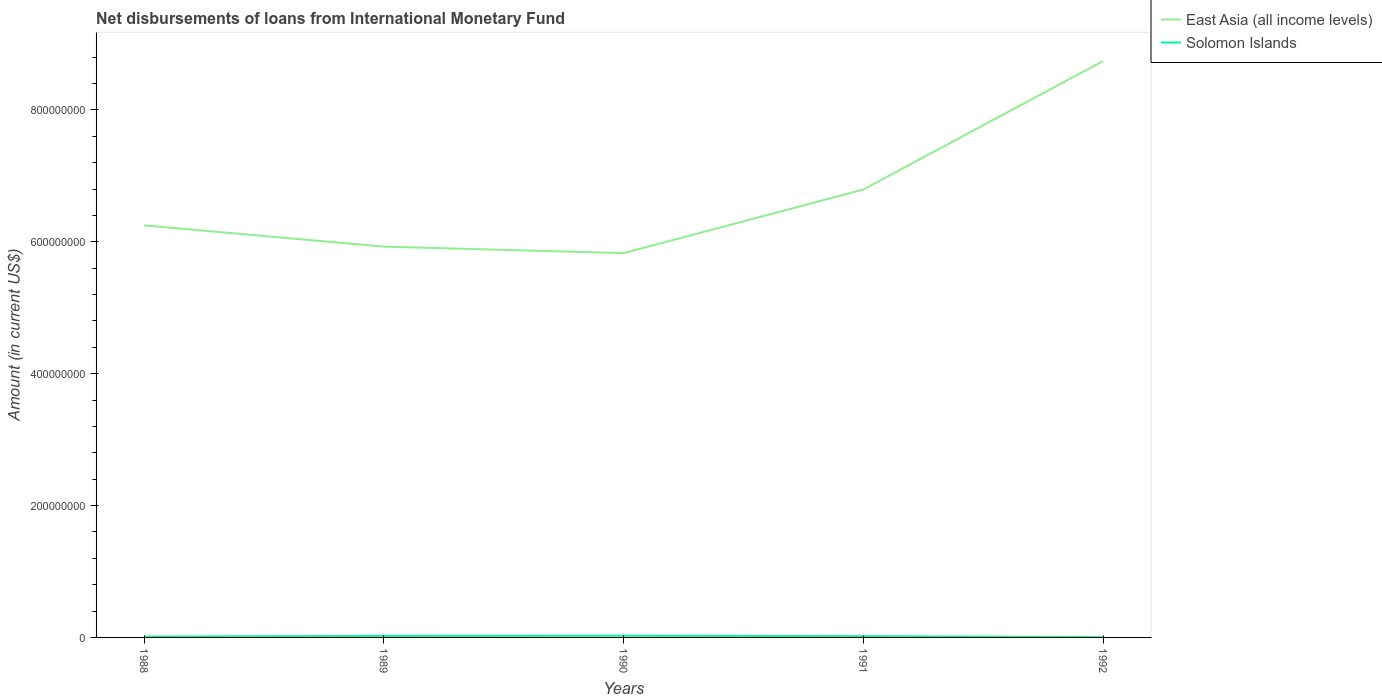Across all years, what is the maximum amount of loans disbursed in Solomon Islands?
Provide a succinct answer. 4.98e+05. In which year was the amount of loans disbursed in East Asia (all income levels) maximum?
Offer a terse response. 1990. What is the total amount of loans disbursed in Solomon Islands in the graph?
Offer a very short reply. 8.05e+05. What is the difference between the highest and the second highest amount of loans disbursed in Solomon Islands?
Ensure brevity in your answer.  2.05e+06. Is the amount of loans disbursed in East Asia (all income levels) strictly greater than the amount of loans disbursed in Solomon Islands over the years?
Provide a short and direct response. No. How many lines are there?
Keep it short and to the point. 2. How many years are there in the graph?
Your response must be concise. 5. How are the legend labels stacked?
Your response must be concise. Vertical. What is the title of the graph?
Ensure brevity in your answer.  Net disbursements of loans from International Monetary Fund. What is the label or title of the X-axis?
Give a very brief answer. Years. What is the label or title of the Y-axis?
Provide a short and direct response. Amount (in current US$). What is the Amount (in current US$) of East Asia (all income levels) in 1988?
Offer a very short reply. 6.25e+08. What is the Amount (in current US$) in Solomon Islands in 1988?
Make the answer very short. 1.30e+06. What is the Amount (in current US$) of East Asia (all income levels) in 1989?
Keep it short and to the point. 5.93e+08. What is the Amount (in current US$) in Solomon Islands in 1989?
Ensure brevity in your answer.  2.28e+06. What is the Amount (in current US$) in East Asia (all income levels) in 1990?
Give a very brief answer. 5.83e+08. What is the Amount (in current US$) in Solomon Islands in 1990?
Your answer should be compact. 2.54e+06. What is the Amount (in current US$) of East Asia (all income levels) in 1991?
Offer a terse response. 6.79e+08. What is the Amount (in current US$) in Solomon Islands in 1991?
Keep it short and to the point. 1.92e+06. What is the Amount (in current US$) in East Asia (all income levels) in 1992?
Provide a short and direct response. 8.74e+08. What is the Amount (in current US$) in Solomon Islands in 1992?
Provide a succinct answer. 4.98e+05. Across all years, what is the maximum Amount (in current US$) in East Asia (all income levels)?
Your answer should be very brief. 8.74e+08. Across all years, what is the maximum Amount (in current US$) in Solomon Islands?
Your answer should be compact. 2.54e+06. Across all years, what is the minimum Amount (in current US$) in East Asia (all income levels)?
Ensure brevity in your answer.  5.83e+08. Across all years, what is the minimum Amount (in current US$) of Solomon Islands?
Your answer should be compact. 4.98e+05. What is the total Amount (in current US$) in East Asia (all income levels) in the graph?
Keep it short and to the point. 3.35e+09. What is the total Amount (in current US$) in Solomon Islands in the graph?
Make the answer very short. 8.55e+06. What is the difference between the Amount (in current US$) in East Asia (all income levels) in 1988 and that in 1989?
Your response must be concise. 3.22e+07. What is the difference between the Amount (in current US$) in Solomon Islands in 1988 and that in 1989?
Ensure brevity in your answer.  -9.78e+05. What is the difference between the Amount (in current US$) of East Asia (all income levels) in 1988 and that in 1990?
Provide a short and direct response. 4.21e+07. What is the difference between the Amount (in current US$) in Solomon Islands in 1988 and that in 1990?
Your answer should be compact. -1.24e+06. What is the difference between the Amount (in current US$) in East Asia (all income levels) in 1988 and that in 1991?
Offer a very short reply. -5.43e+07. What is the difference between the Amount (in current US$) in Solomon Islands in 1988 and that in 1991?
Your response must be concise. -6.17e+05. What is the difference between the Amount (in current US$) in East Asia (all income levels) in 1988 and that in 1992?
Ensure brevity in your answer.  -2.49e+08. What is the difference between the Amount (in current US$) in Solomon Islands in 1988 and that in 1992?
Keep it short and to the point. 8.05e+05. What is the difference between the Amount (in current US$) of East Asia (all income levels) in 1989 and that in 1990?
Provide a short and direct response. 9.87e+06. What is the difference between the Amount (in current US$) in Solomon Islands in 1989 and that in 1990?
Offer a terse response. -2.63e+05. What is the difference between the Amount (in current US$) in East Asia (all income levels) in 1989 and that in 1991?
Provide a short and direct response. -8.66e+07. What is the difference between the Amount (in current US$) of Solomon Islands in 1989 and that in 1991?
Provide a succinct answer. 3.61e+05. What is the difference between the Amount (in current US$) of East Asia (all income levels) in 1989 and that in 1992?
Your response must be concise. -2.81e+08. What is the difference between the Amount (in current US$) of Solomon Islands in 1989 and that in 1992?
Offer a very short reply. 1.78e+06. What is the difference between the Amount (in current US$) of East Asia (all income levels) in 1990 and that in 1991?
Provide a succinct answer. -9.64e+07. What is the difference between the Amount (in current US$) in Solomon Islands in 1990 and that in 1991?
Keep it short and to the point. 6.24e+05. What is the difference between the Amount (in current US$) of East Asia (all income levels) in 1990 and that in 1992?
Your answer should be compact. -2.91e+08. What is the difference between the Amount (in current US$) in Solomon Islands in 1990 and that in 1992?
Give a very brief answer. 2.05e+06. What is the difference between the Amount (in current US$) of East Asia (all income levels) in 1991 and that in 1992?
Your answer should be compact. -1.95e+08. What is the difference between the Amount (in current US$) in Solomon Islands in 1991 and that in 1992?
Make the answer very short. 1.42e+06. What is the difference between the Amount (in current US$) of East Asia (all income levels) in 1988 and the Amount (in current US$) of Solomon Islands in 1989?
Give a very brief answer. 6.23e+08. What is the difference between the Amount (in current US$) of East Asia (all income levels) in 1988 and the Amount (in current US$) of Solomon Islands in 1990?
Provide a succinct answer. 6.22e+08. What is the difference between the Amount (in current US$) of East Asia (all income levels) in 1988 and the Amount (in current US$) of Solomon Islands in 1991?
Keep it short and to the point. 6.23e+08. What is the difference between the Amount (in current US$) in East Asia (all income levels) in 1988 and the Amount (in current US$) in Solomon Islands in 1992?
Ensure brevity in your answer.  6.24e+08. What is the difference between the Amount (in current US$) in East Asia (all income levels) in 1989 and the Amount (in current US$) in Solomon Islands in 1990?
Your response must be concise. 5.90e+08. What is the difference between the Amount (in current US$) in East Asia (all income levels) in 1989 and the Amount (in current US$) in Solomon Islands in 1991?
Your answer should be compact. 5.91e+08. What is the difference between the Amount (in current US$) of East Asia (all income levels) in 1989 and the Amount (in current US$) of Solomon Islands in 1992?
Ensure brevity in your answer.  5.92e+08. What is the difference between the Amount (in current US$) in East Asia (all income levels) in 1990 and the Amount (in current US$) in Solomon Islands in 1991?
Keep it short and to the point. 5.81e+08. What is the difference between the Amount (in current US$) of East Asia (all income levels) in 1990 and the Amount (in current US$) of Solomon Islands in 1992?
Offer a very short reply. 5.82e+08. What is the difference between the Amount (in current US$) in East Asia (all income levels) in 1991 and the Amount (in current US$) in Solomon Islands in 1992?
Provide a succinct answer. 6.79e+08. What is the average Amount (in current US$) of East Asia (all income levels) per year?
Ensure brevity in your answer.  6.71e+08. What is the average Amount (in current US$) in Solomon Islands per year?
Provide a short and direct response. 1.71e+06. In the year 1988, what is the difference between the Amount (in current US$) in East Asia (all income levels) and Amount (in current US$) in Solomon Islands?
Offer a terse response. 6.24e+08. In the year 1989, what is the difference between the Amount (in current US$) of East Asia (all income levels) and Amount (in current US$) of Solomon Islands?
Provide a succinct answer. 5.90e+08. In the year 1990, what is the difference between the Amount (in current US$) of East Asia (all income levels) and Amount (in current US$) of Solomon Islands?
Ensure brevity in your answer.  5.80e+08. In the year 1991, what is the difference between the Amount (in current US$) in East Asia (all income levels) and Amount (in current US$) in Solomon Islands?
Give a very brief answer. 6.77e+08. In the year 1992, what is the difference between the Amount (in current US$) in East Asia (all income levels) and Amount (in current US$) in Solomon Islands?
Your answer should be compact. 8.74e+08. What is the ratio of the Amount (in current US$) of East Asia (all income levels) in 1988 to that in 1989?
Offer a very short reply. 1.05. What is the ratio of the Amount (in current US$) in Solomon Islands in 1988 to that in 1989?
Provide a succinct answer. 0.57. What is the ratio of the Amount (in current US$) of East Asia (all income levels) in 1988 to that in 1990?
Make the answer very short. 1.07. What is the ratio of the Amount (in current US$) in Solomon Islands in 1988 to that in 1990?
Offer a very short reply. 0.51. What is the ratio of the Amount (in current US$) of Solomon Islands in 1988 to that in 1991?
Your answer should be compact. 0.68. What is the ratio of the Amount (in current US$) of East Asia (all income levels) in 1988 to that in 1992?
Your answer should be compact. 0.71. What is the ratio of the Amount (in current US$) of Solomon Islands in 1988 to that in 1992?
Provide a succinct answer. 2.62. What is the ratio of the Amount (in current US$) in East Asia (all income levels) in 1989 to that in 1990?
Make the answer very short. 1.02. What is the ratio of the Amount (in current US$) of Solomon Islands in 1989 to that in 1990?
Ensure brevity in your answer.  0.9. What is the ratio of the Amount (in current US$) of East Asia (all income levels) in 1989 to that in 1991?
Offer a very short reply. 0.87. What is the ratio of the Amount (in current US$) of Solomon Islands in 1989 to that in 1991?
Ensure brevity in your answer.  1.19. What is the ratio of the Amount (in current US$) in East Asia (all income levels) in 1989 to that in 1992?
Provide a short and direct response. 0.68. What is the ratio of the Amount (in current US$) of Solomon Islands in 1989 to that in 1992?
Make the answer very short. 4.58. What is the ratio of the Amount (in current US$) of East Asia (all income levels) in 1990 to that in 1991?
Offer a terse response. 0.86. What is the ratio of the Amount (in current US$) in Solomon Islands in 1990 to that in 1991?
Give a very brief answer. 1.32. What is the ratio of the Amount (in current US$) in East Asia (all income levels) in 1990 to that in 1992?
Your answer should be compact. 0.67. What is the ratio of the Amount (in current US$) in Solomon Islands in 1990 to that in 1992?
Your response must be concise. 5.11. What is the ratio of the Amount (in current US$) in East Asia (all income levels) in 1991 to that in 1992?
Offer a terse response. 0.78. What is the ratio of the Amount (in current US$) in Solomon Islands in 1991 to that in 1992?
Ensure brevity in your answer.  3.86. What is the difference between the highest and the second highest Amount (in current US$) in East Asia (all income levels)?
Provide a short and direct response. 1.95e+08. What is the difference between the highest and the second highest Amount (in current US$) of Solomon Islands?
Ensure brevity in your answer.  2.63e+05. What is the difference between the highest and the lowest Amount (in current US$) of East Asia (all income levels)?
Your response must be concise. 2.91e+08. What is the difference between the highest and the lowest Amount (in current US$) in Solomon Islands?
Provide a short and direct response. 2.05e+06. 